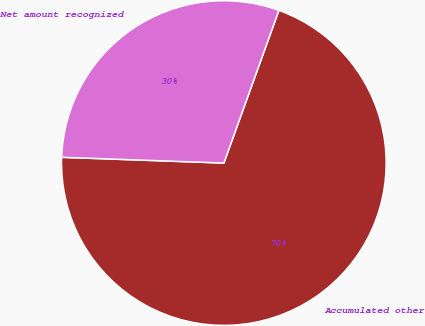<chart> <loc_0><loc_0><loc_500><loc_500><pie_chart><fcel>Accumulated other<fcel>Net amount recognized<nl><fcel>70.06%<fcel>29.94%<nl></chart> 